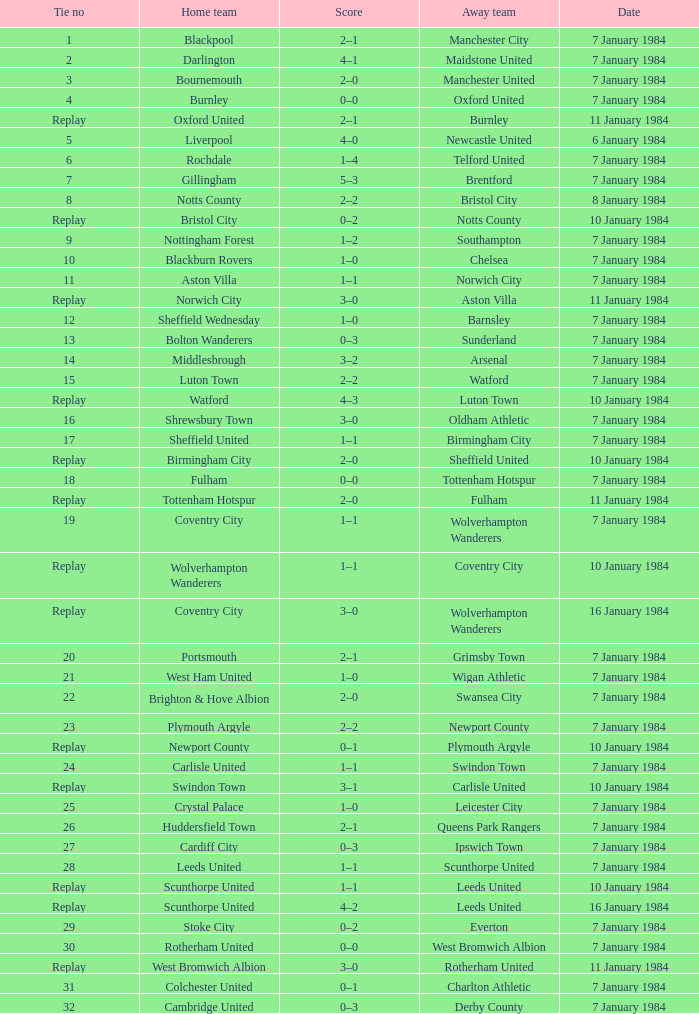Who was the away team against the home team Sheffield United? Birmingham City. 